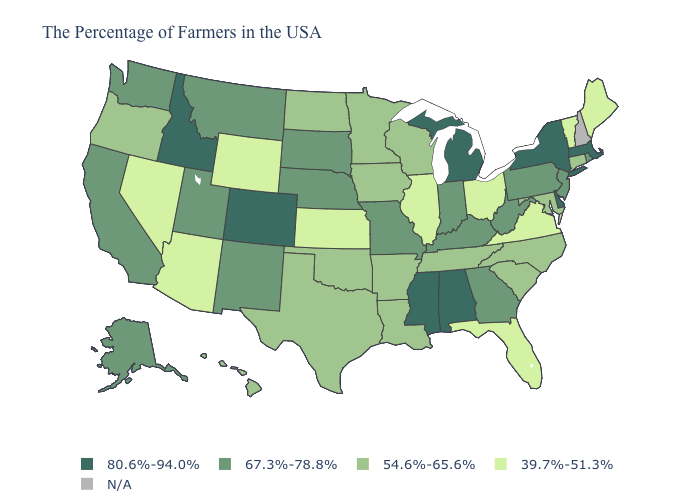Among the states that border Wyoming , which have the highest value?
Give a very brief answer. Colorado, Idaho. What is the lowest value in the USA?
Concise answer only. 39.7%-51.3%. What is the value of Alaska?
Write a very short answer. 67.3%-78.8%. What is the lowest value in the USA?
Be succinct. 39.7%-51.3%. Among the states that border Nevada , which have the highest value?
Answer briefly. Idaho. What is the value of West Virginia?
Keep it brief. 67.3%-78.8%. What is the value of Hawaii?
Quick response, please. 54.6%-65.6%. What is the value of South Dakota?
Be succinct. 67.3%-78.8%. What is the highest value in the USA?
Short answer required. 80.6%-94.0%. Does Colorado have the highest value in the West?
Write a very short answer. Yes. Among the states that border California , does Arizona have the lowest value?
Concise answer only. Yes. Does South Dakota have the highest value in the USA?
Keep it brief. No. What is the value of Rhode Island?
Write a very short answer. 67.3%-78.8%. 